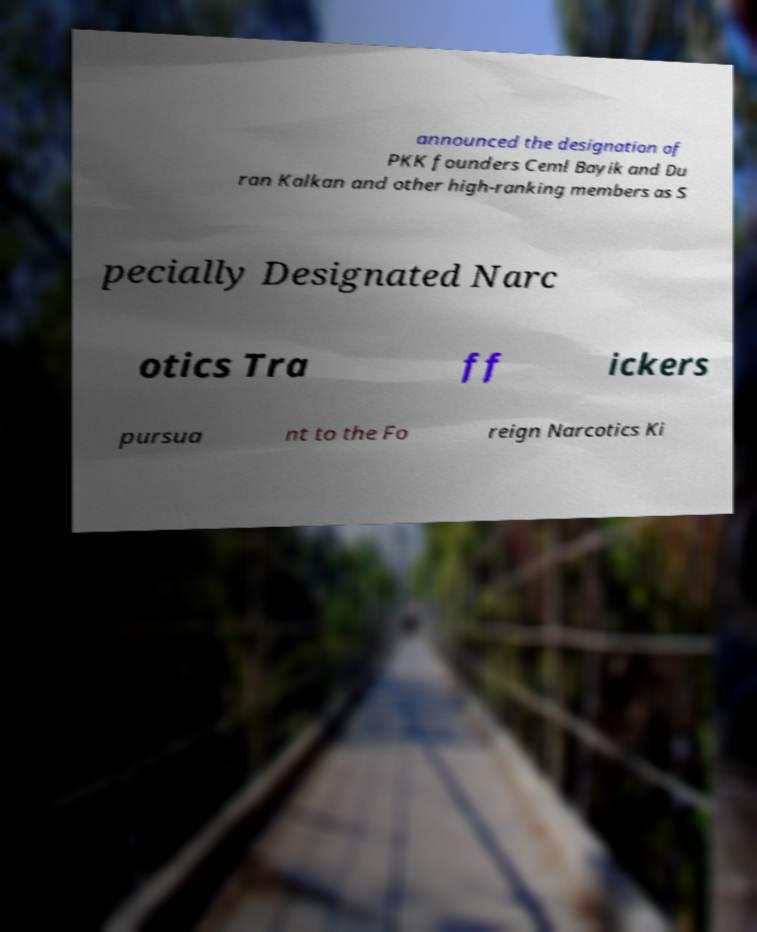What messages or text are displayed in this image? I need them in a readable, typed format. announced the designation of PKK founders Ceml Bayik and Du ran Kalkan and other high-ranking members as S pecially Designated Narc otics Tra ff ickers pursua nt to the Fo reign Narcotics Ki 